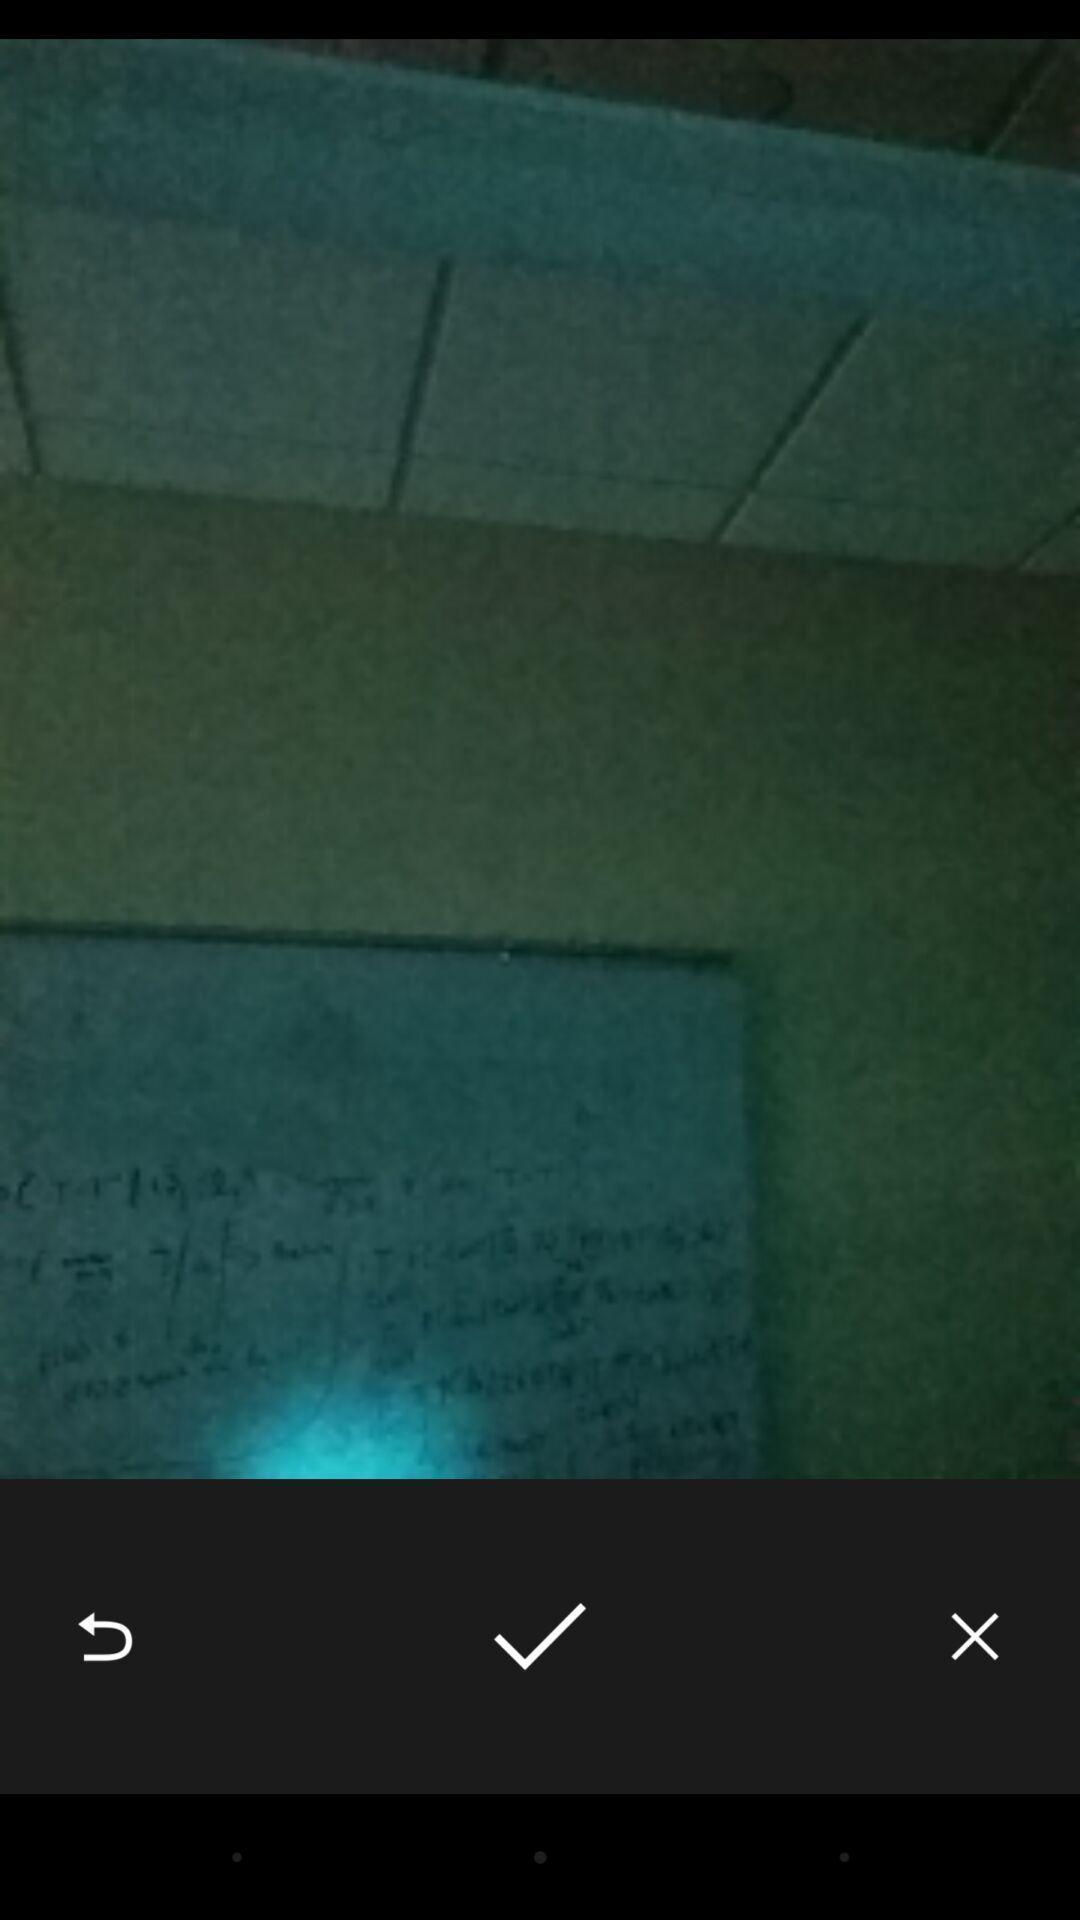Explain what's happening in this screen capture. Taking a photo of board in the app. 